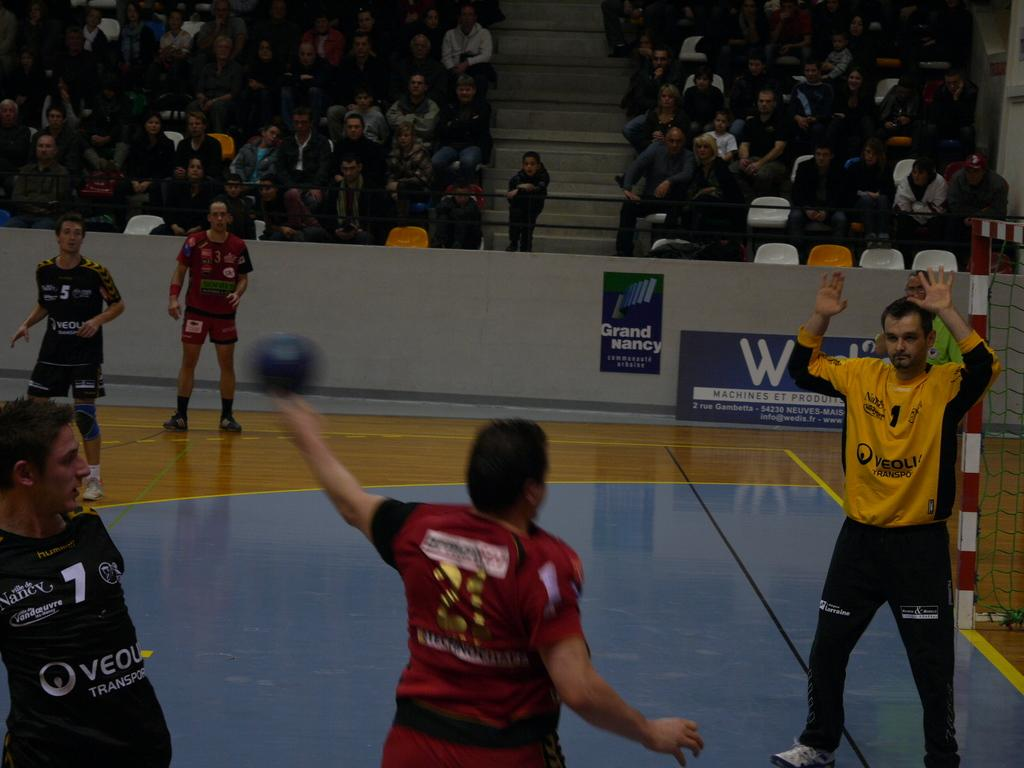<image>
Describe the image concisely. A large W can be seen on an ad with people playing a game in front of it. 